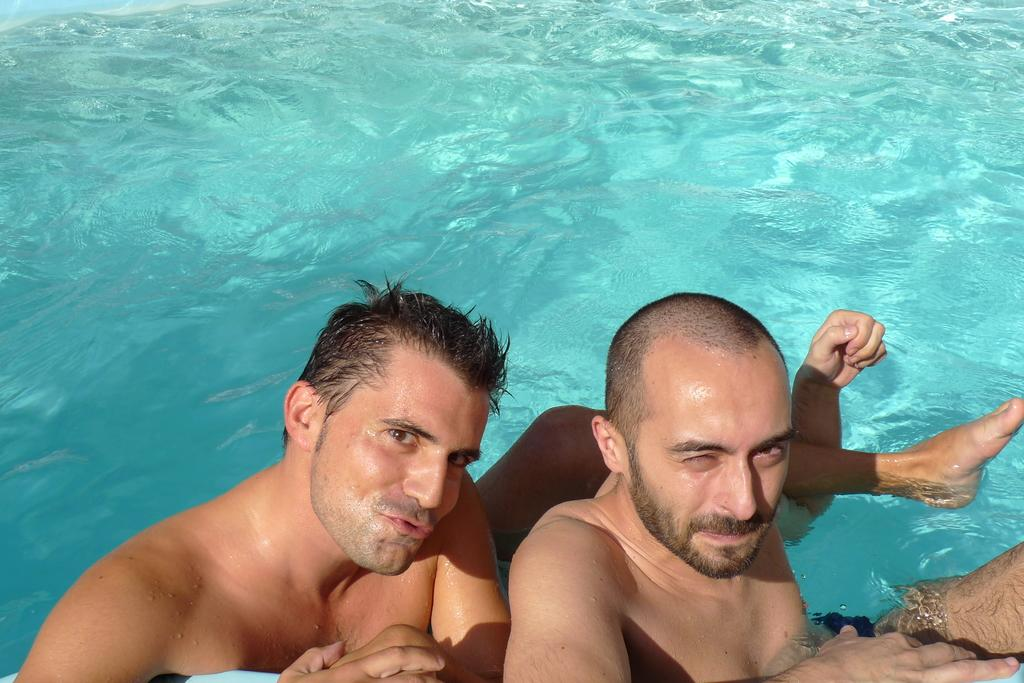How many people are in the image? There are two men in the image. What is the setting of the image? The men are in the water. What statement does the organization make about the route in the image? There is no organization or statement mentioned in the image, as it only features two men in the water. 